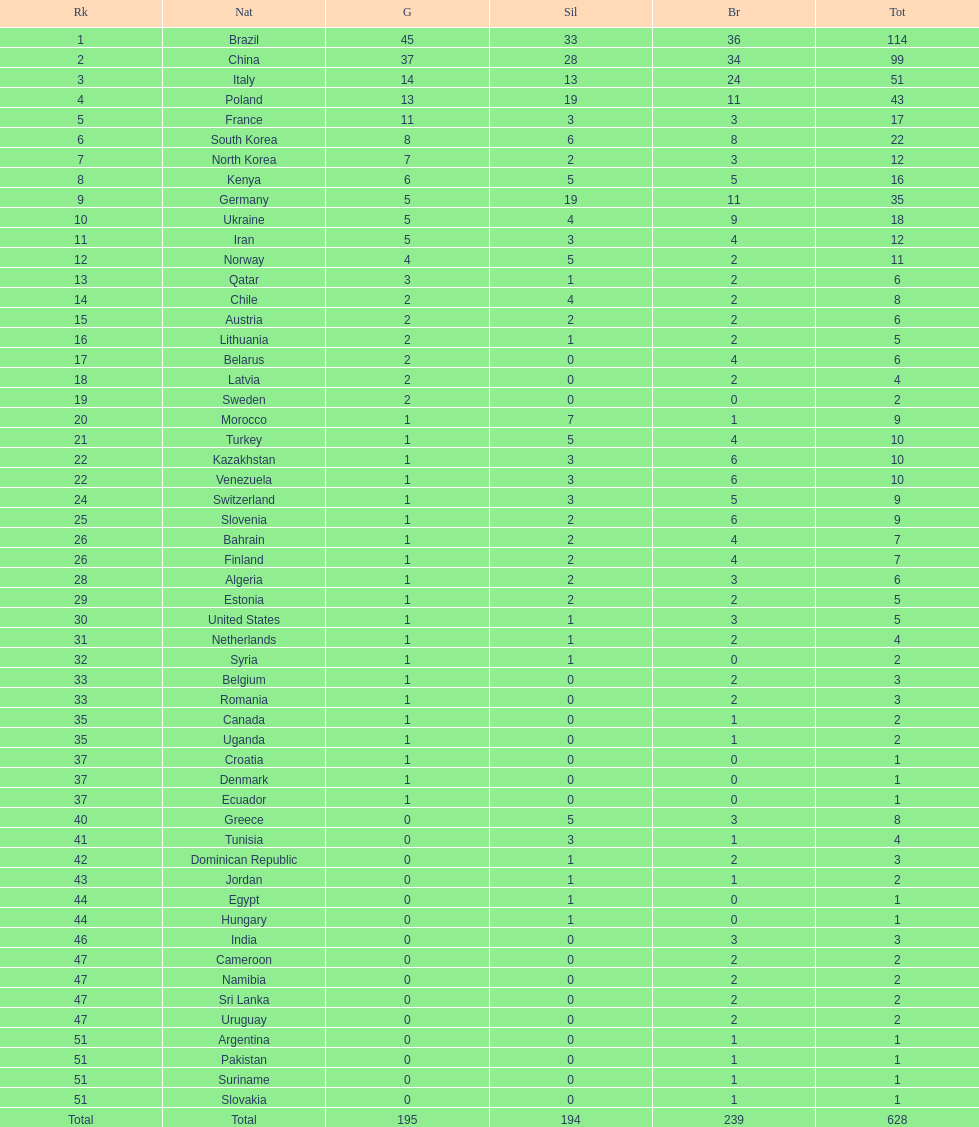Who only won 13 silver medals? Italy. 